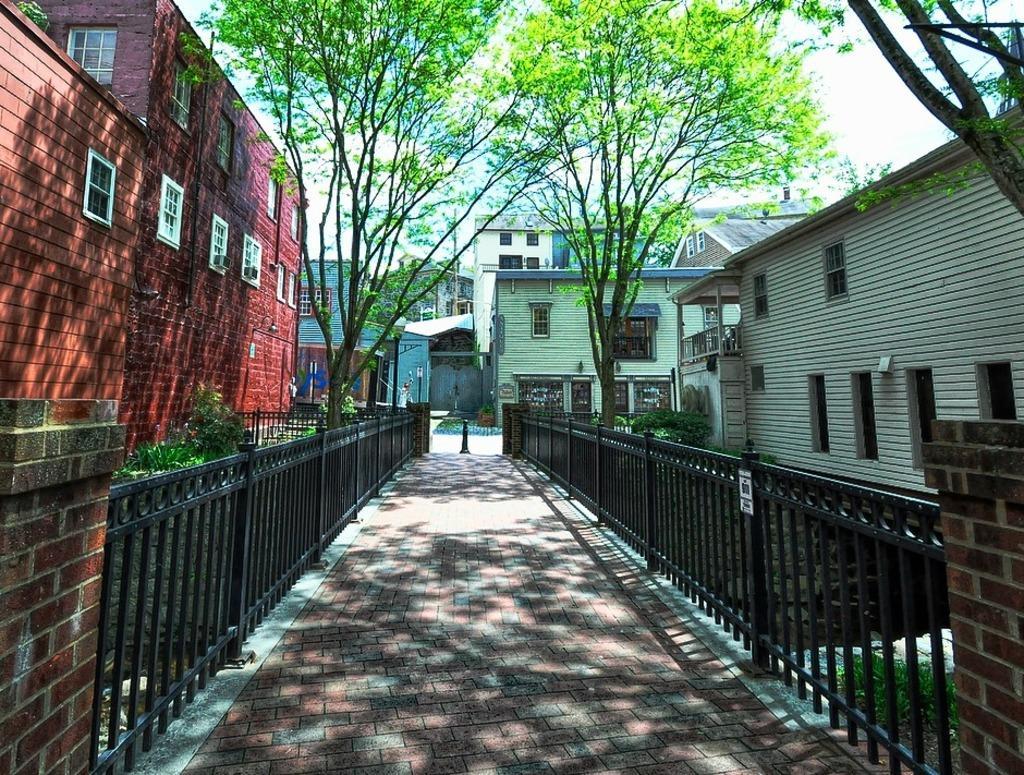Please provide a concise description of this image. There is a road. On both sides of the road, there is fencing attached to the pillar. In the background, there are trees, buildings which are having glass windows and there are clouds in the blue sky. 